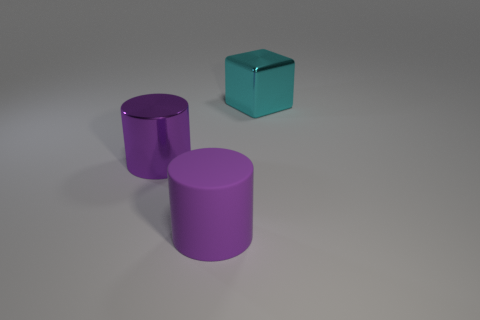Is there any other thing that is made of the same material as the large cube?
Your answer should be very brief. Yes. There is a big shiny thing to the left of the rubber cylinder; what color is it?
Ensure brevity in your answer.  Purple. Does the large cyan block have the same material as the big purple cylinder in front of the purple metal cylinder?
Give a very brief answer. No. What material is the block?
Offer a very short reply. Metal. What number of other objects are the same shape as the large purple matte object?
Make the answer very short. 1. There is a big metallic cube; how many large purple rubber cylinders are on the left side of it?
Your answer should be very brief. 1. Is the size of the purple cylinder in front of the big purple metallic cylinder the same as the shiny object behind the metallic cylinder?
Offer a terse response. Yes. What number of other objects are there of the same size as the matte thing?
Give a very brief answer. 2. What is the material of the purple object that is behind the large object in front of the purple metallic cylinder behind the large purple matte thing?
Make the answer very short. Metal. Is the size of the matte object the same as the metal thing left of the cyan object?
Offer a very short reply. Yes. 